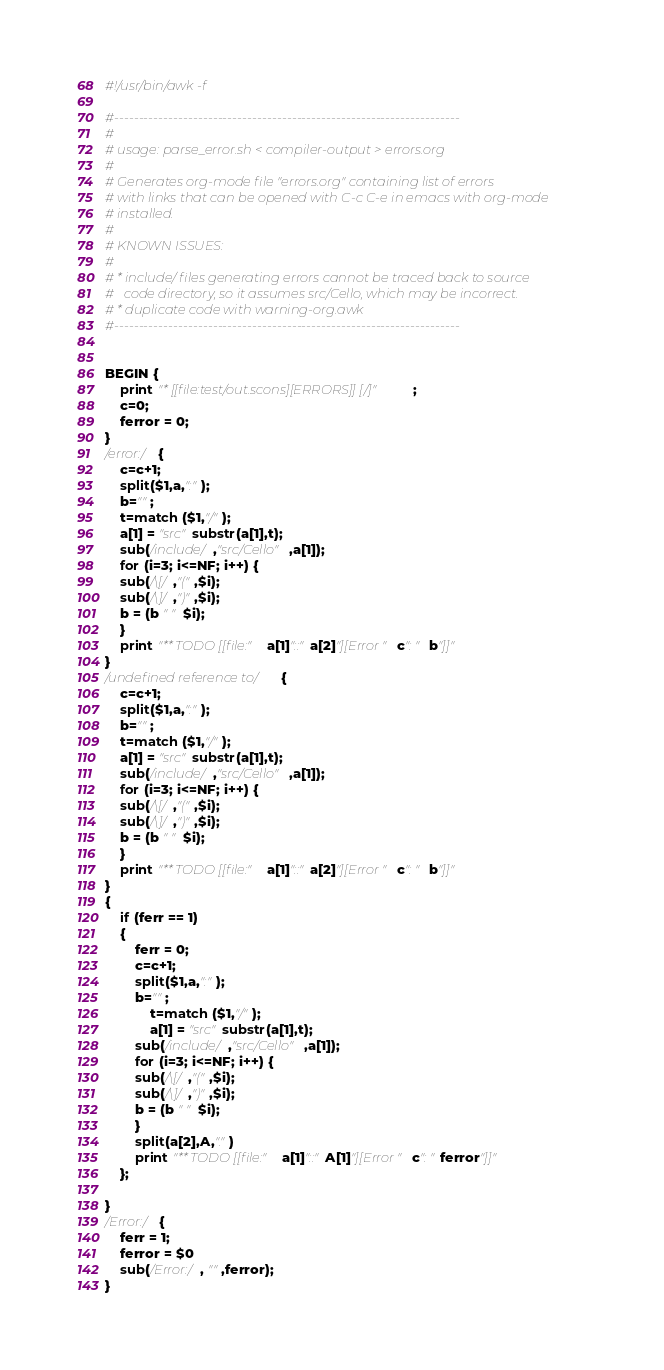Convert code to text. <code><loc_0><loc_0><loc_500><loc_500><_Awk_>#!/usr/bin/awk -f

#----------------------------------------------------------------------
#
# usage: parse_error.sh < compiler-output > errors.org
#
# Generates org-mode file "errors.org" containing list of errors
# with links that can be opened with C-c C-e in emacs with org-mode
# installed.
#
# KNOWN ISSUES:
#
# * include/ files generating errors cannot be traced back to source
#   code directory, so it assumes src/Cello, which may be incorrect.
# * duplicate code with warning-org.awk
#----------------------------------------------------------------------


BEGIN {
    print "* [[file:test/out.scons][ERRORS]] [/]";
    c=0;
    ferror = 0;
}
/error:/ {
    c=c+1; 
    split($1,a,":"); 
    b="";  
    t=match ($1,"/");
    a[1] = "src"substr(a[1],t);
    sub(/include/,"src/Cello",a[1]);
    for (i=3; i<=NF; i++) {
	sub(/\[/,"(",$i);
	sub(/\]/,")",$i);
	b = (b " " $i); 
    }
    print "** TODO [[file:"a[1]"::"a[2]"][Error "c": " b"]]"
}
/undefined reference to/ {
    c=c+1; 
    split($1,a,":"); 
    b="";  
    t=match ($1,"/");
    a[1] = "src"substr(a[1],t);
    sub(/include/,"src/Cello",a[1]);
    for (i=3; i<=NF; i++) {
	sub(/\[/,"(",$i);
	sub(/\]/,")",$i);
	b = (b " " $i); 
    }
    print "** TODO [[file:"a[1]"::"a[2]"][Error "c": " b"]]"
}
{
    if (ferr == 1) 
	{
	    ferr = 0;
	    c=c+1; 
	    split($1,a,":"); 
	    b="";  
            t=match ($1,"/");
            a[1] = "src"substr(a[1],t);
	    sub(/include/,"src/Cello",a[1]);
	    for (i=3; i<=NF; i++) {
		sub(/\[/,"(",$i);
		sub(/\]/,")",$i);
		b = (b " " $i); 
	    }
	    split(a[2],A,".")
	    print "** TODO [[file:"a[1]"::"A[1]"][Error "c": "ferror"]]"
	};
	
}
/Error:/ {
    ferr = 1;
    ferror = $0
    sub(/Error:/, "",ferror); 
}
</code> 